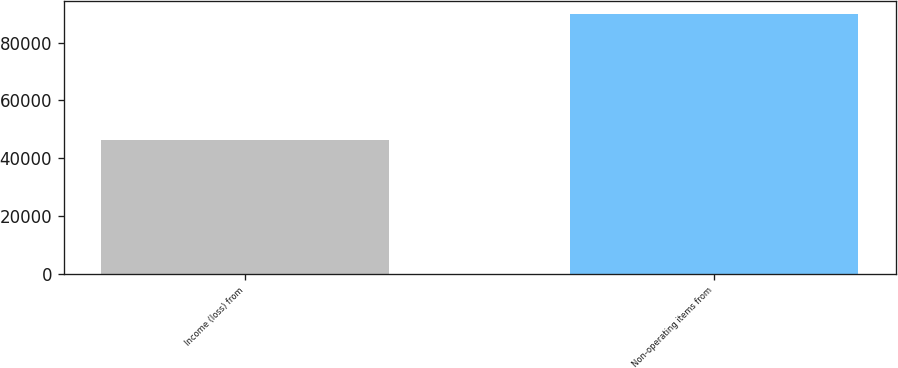Convert chart. <chart><loc_0><loc_0><loc_500><loc_500><bar_chart><fcel>Income (loss) from<fcel>Non-operating items from<nl><fcel>46382<fcel>90020<nl></chart> 